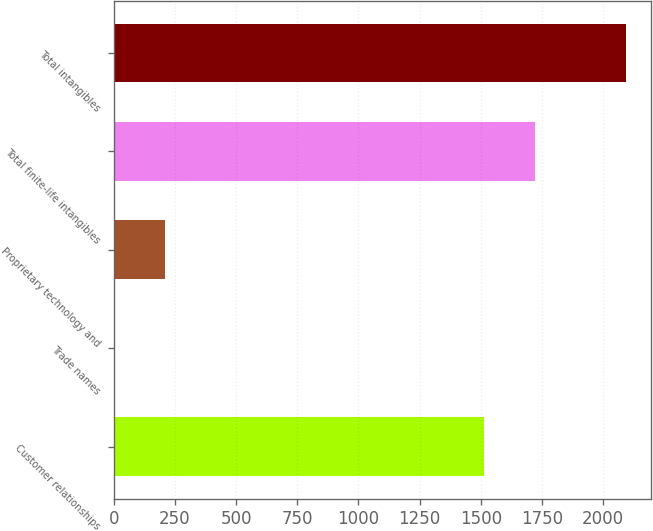<chart> <loc_0><loc_0><loc_500><loc_500><bar_chart><fcel>Customer relationships<fcel>Trade names<fcel>Proprietary technology and<fcel>Total finite-life intangibles<fcel>Total intangibles<nl><fcel>1513.9<fcel>1.5<fcel>210.5<fcel>1722.9<fcel>2091.5<nl></chart> 